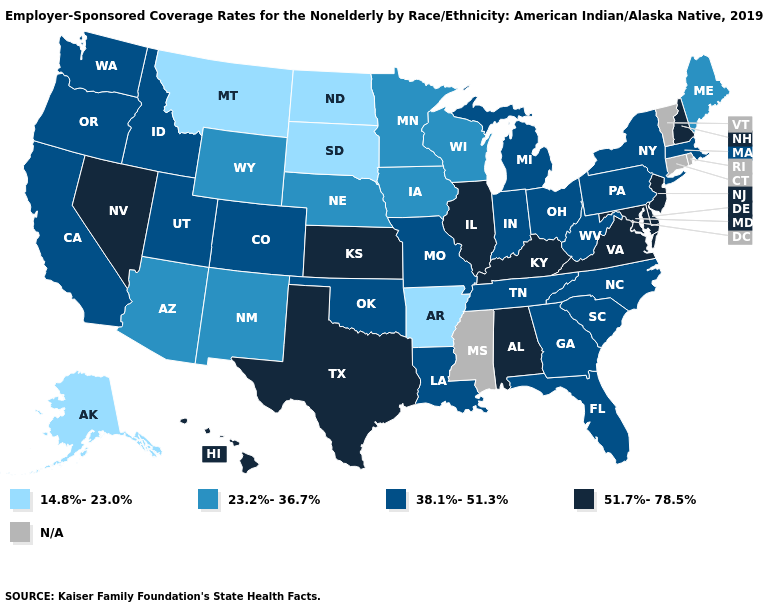What is the highest value in the USA?
Write a very short answer. 51.7%-78.5%. How many symbols are there in the legend?
Give a very brief answer. 5. What is the value of Virginia?
Write a very short answer. 51.7%-78.5%. What is the lowest value in states that border Texas?
Keep it brief. 14.8%-23.0%. Name the states that have a value in the range 14.8%-23.0%?
Concise answer only. Alaska, Arkansas, Montana, North Dakota, South Dakota. What is the highest value in states that border New Mexico?
Write a very short answer. 51.7%-78.5%. What is the value of Illinois?
Short answer required. 51.7%-78.5%. Is the legend a continuous bar?
Write a very short answer. No. What is the lowest value in the USA?
Write a very short answer. 14.8%-23.0%. Which states have the highest value in the USA?
Short answer required. Alabama, Delaware, Hawaii, Illinois, Kansas, Kentucky, Maryland, Nevada, New Hampshire, New Jersey, Texas, Virginia. Does New Mexico have the highest value in the USA?
Give a very brief answer. No. What is the value of Oklahoma?
Concise answer only. 38.1%-51.3%. Name the states that have a value in the range N/A?
Quick response, please. Connecticut, Mississippi, Rhode Island, Vermont. Name the states that have a value in the range 23.2%-36.7%?
Quick response, please. Arizona, Iowa, Maine, Minnesota, Nebraska, New Mexico, Wisconsin, Wyoming. What is the lowest value in the USA?
Write a very short answer. 14.8%-23.0%. 